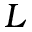<formula> <loc_0><loc_0><loc_500><loc_500>L</formula> 